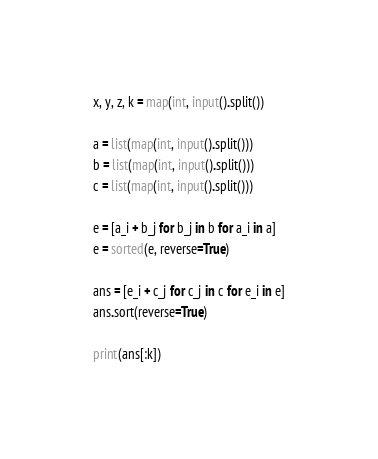Convert code to text. <code><loc_0><loc_0><loc_500><loc_500><_Python_>x, y, z, k = map(int, input().split())

a = list(map(int, input().split()))
b = list(map(int, input().split()))
c = list(map(int, input().split()))

e = [a_i + b_j for b_j in b for a_i in a]
e = sorted(e, reverse=True)

ans = [e_i + c_j for c_j in c for e_i in e]
ans.sort(reverse=True)

print(ans[:k])</code> 